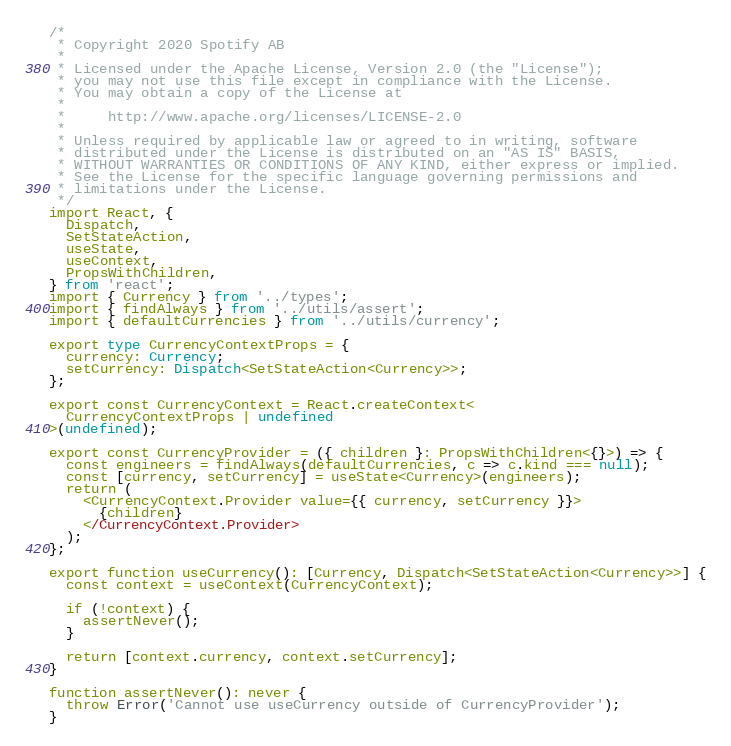<code> <loc_0><loc_0><loc_500><loc_500><_TypeScript_>/*
 * Copyright 2020 Spotify AB
 *
 * Licensed under the Apache License, Version 2.0 (the "License");
 * you may not use this file except in compliance with the License.
 * You may obtain a copy of the License at
 *
 *     http://www.apache.org/licenses/LICENSE-2.0
 *
 * Unless required by applicable law or agreed to in writing, software
 * distributed under the License is distributed on an "AS IS" BASIS,
 * WITHOUT WARRANTIES OR CONDITIONS OF ANY KIND, either express or implied.
 * See the License for the specific language governing permissions and
 * limitations under the License.
 */
import React, {
  Dispatch,
  SetStateAction,
  useState,
  useContext,
  PropsWithChildren,
} from 'react';
import { Currency } from '../types';
import { findAlways } from '../utils/assert';
import { defaultCurrencies } from '../utils/currency';

export type CurrencyContextProps = {
  currency: Currency;
  setCurrency: Dispatch<SetStateAction<Currency>>;
};

export const CurrencyContext = React.createContext<
  CurrencyContextProps | undefined
>(undefined);

export const CurrencyProvider = ({ children }: PropsWithChildren<{}>) => {
  const engineers = findAlways(defaultCurrencies, c => c.kind === null);
  const [currency, setCurrency] = useState<Currency>(engineers);
  return (
    <CurrencyContext.Provider value={{ currency, setCurrency }}>
      {children}
    </CurrencyContext.Provider>
  );
};

export function useCurrency(): [Currency, Dispatch<SetStateAction<Currency>>] {
  const context = useContext(CurrencyContext);

  if (!context) {
    assertNever();
  }

  return [context.currency, context.setCurrency];
}

function assertNever(): never {
  throw Error('Cannot use useCurrency outside of CurrencyProvider');
}
</code> 